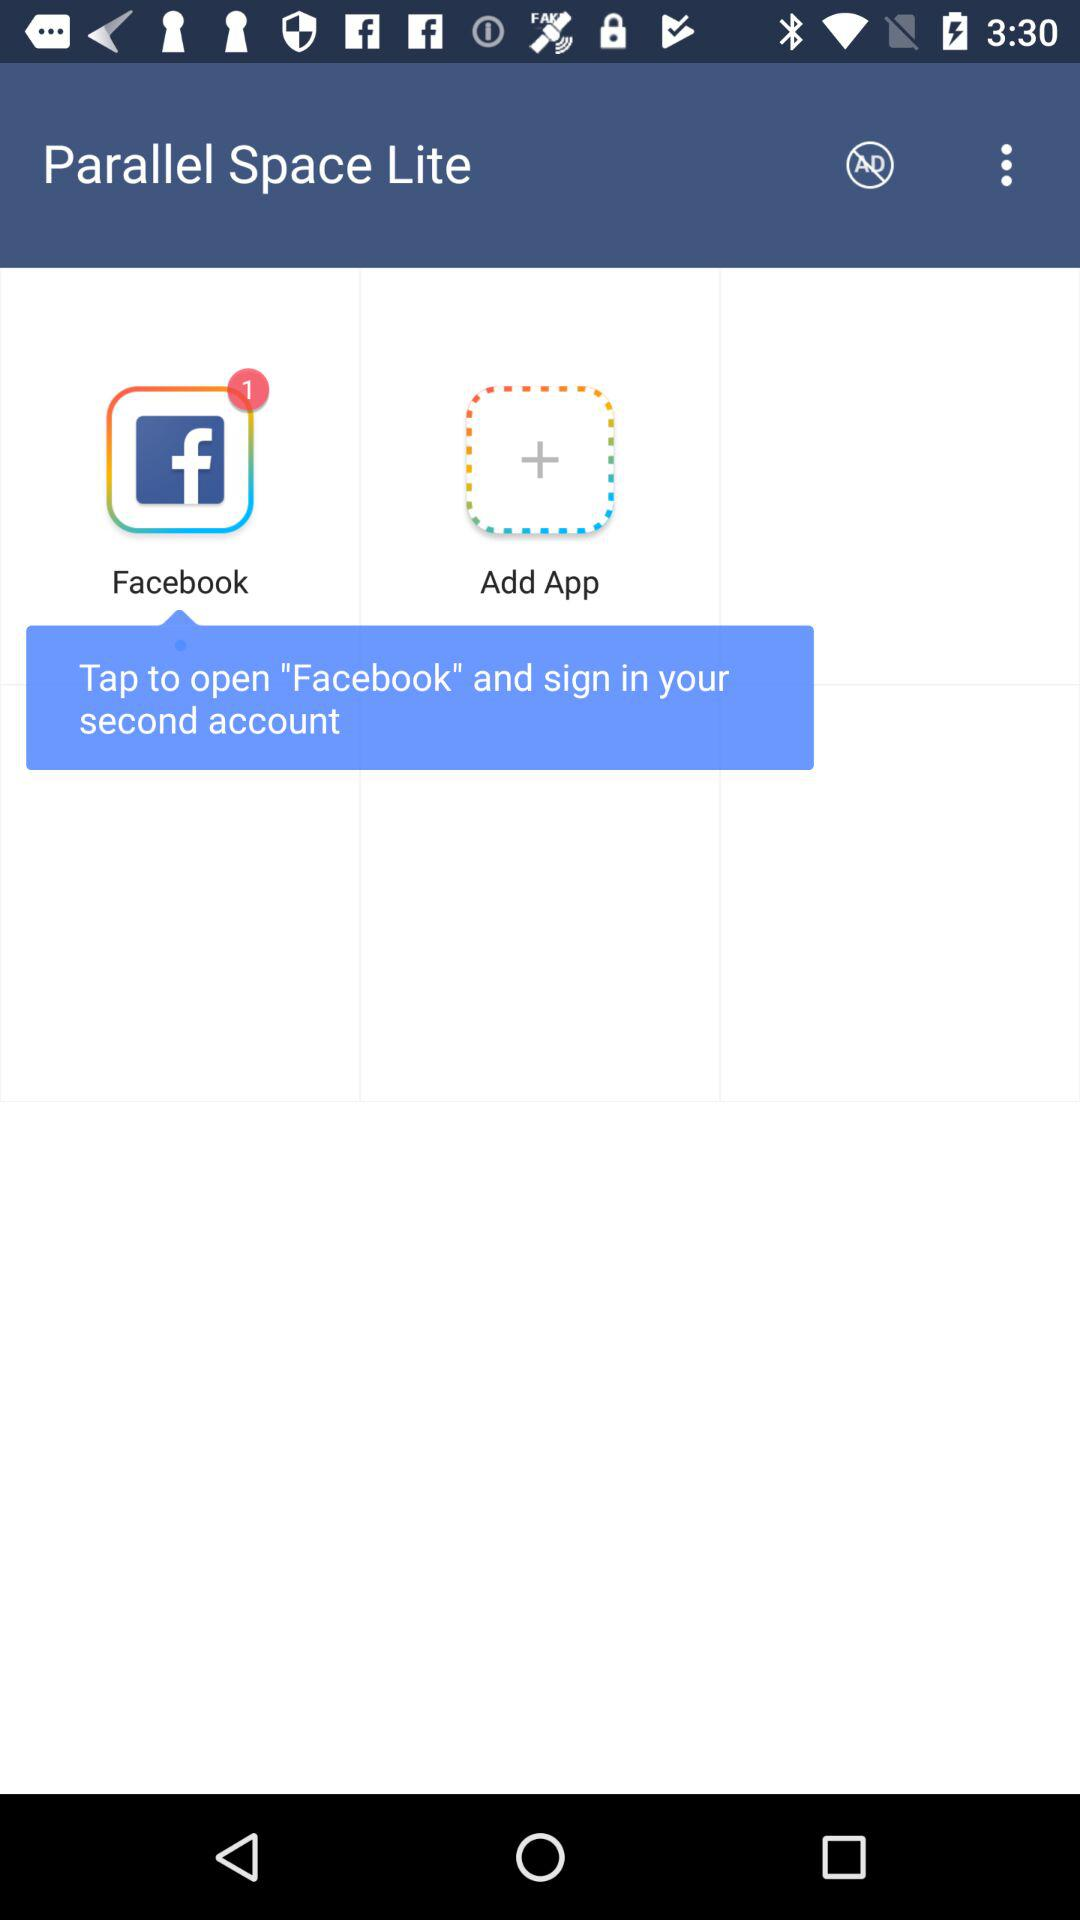What is the number of notifications on "Facebook"? The number of notifications on "Facebook" is 1. 